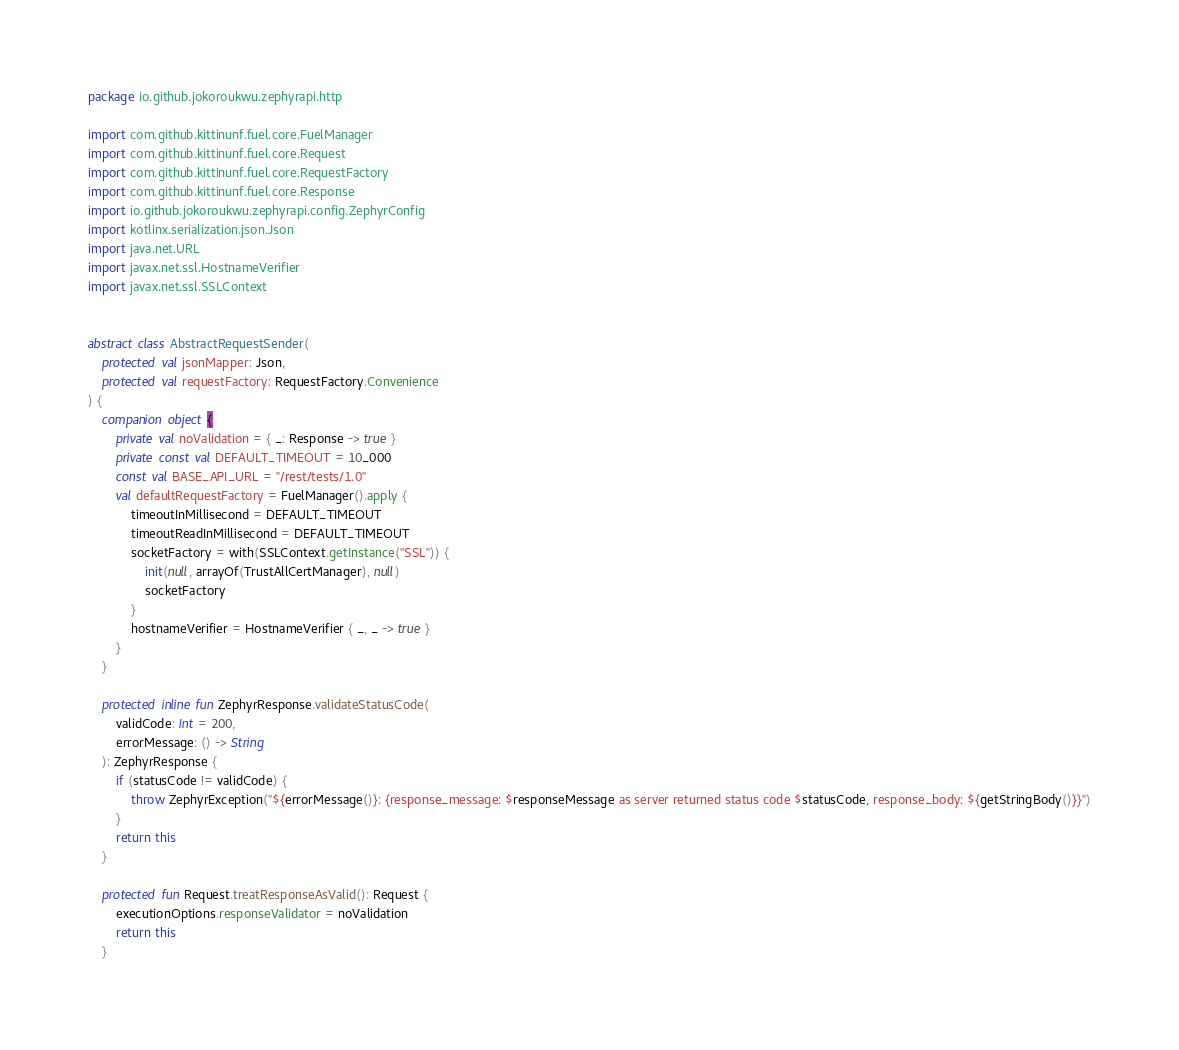<code> <loc_0><loc_0><loc_500><loc_500><_Kotlin_>package io.github.jokoroukwu.zephyrapi.http

import com.github.kittinunf.fuel.core.FuelManager
import com.github.kittinunf.fuel.core.Request
import com.github.kittinunf.fuel.core.RequestFactory
import com.github.kittinunf.fuel.core.Response
import io.github.jokoroukwu.zephyrapi.config.ZephyrConfig
import kotlinx.serialization.json.Json
import java.net.URL
import javax.net.ssl.HostnameVerifier
import javax.net.ssl.SSLContext


abstract class AbstractRequestSender(
    protected val jsonMapper: Json,
    protected val requestFactory: RequestFactory.Convenience
) {
    companion object {
        private val noValidation = { _: Response -> true }
        private const val DEFAULT_TIMEOUT = 10_000
        const val BASE_API_URL = "/rest/tests/1.0"
        val defaultRequestFactory = FuelManager().apply {
            timeoutInMillisecond = DEFAULT_TIMEOUT
            timeoutReadInMillisecond = DEFAULT_TIMEOUT
            socketFactory = with(SSLContext.getInstance("SSL")) {
                init(null, arrayOf(TrustAllCertManager), null)
                socketFactory
            }
            hostnameVerifier = HostnameVerifier { _, _ -> true }
        }
    }

    protected inline fun ZephyrResponse.validateStatusCode(
        validCode: Int = 200,
        errorMessage: () -> String
    ): ZephyrResponse {
        if (statusCode != validCode) {
            throw ZephyrException("${errorMessage()}: {response_message: $responseMessage as server returned status code $statusCode, response_body: ${getStringBody()}}")
        }
        return this
    }

    protected fun Request.treatResponseAsValid(): Request {
        executionOptions.responseValidator = noValidation
        return this
    }
</code> 